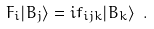<formula> <loc_0><loc_0><loc_500><loc_500>F _ { i } | B _ { j } \rangle = i f _ { i j k } | B _ { k } \rangle \ .</formula> 